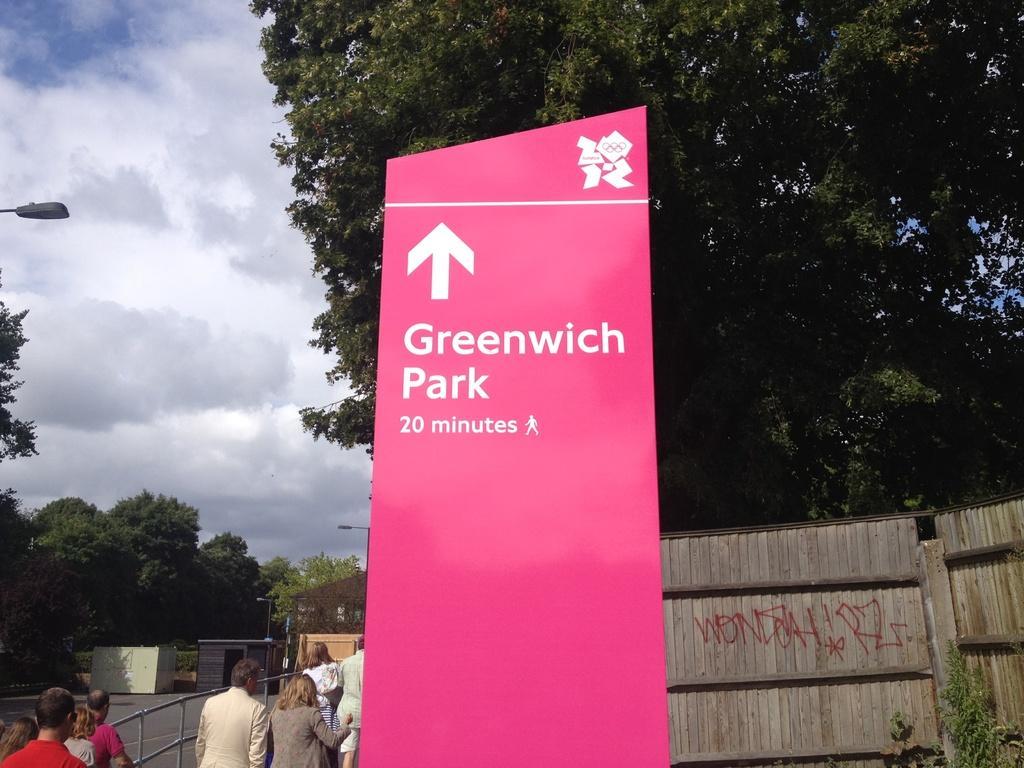Can you describe this image briefly? In this image there is a banner with some text, beside that there are a few people walking, beside them there is a railing. On the right side of the image there are a few wooden houses, In the background there are a few houses, trees and the sky. 